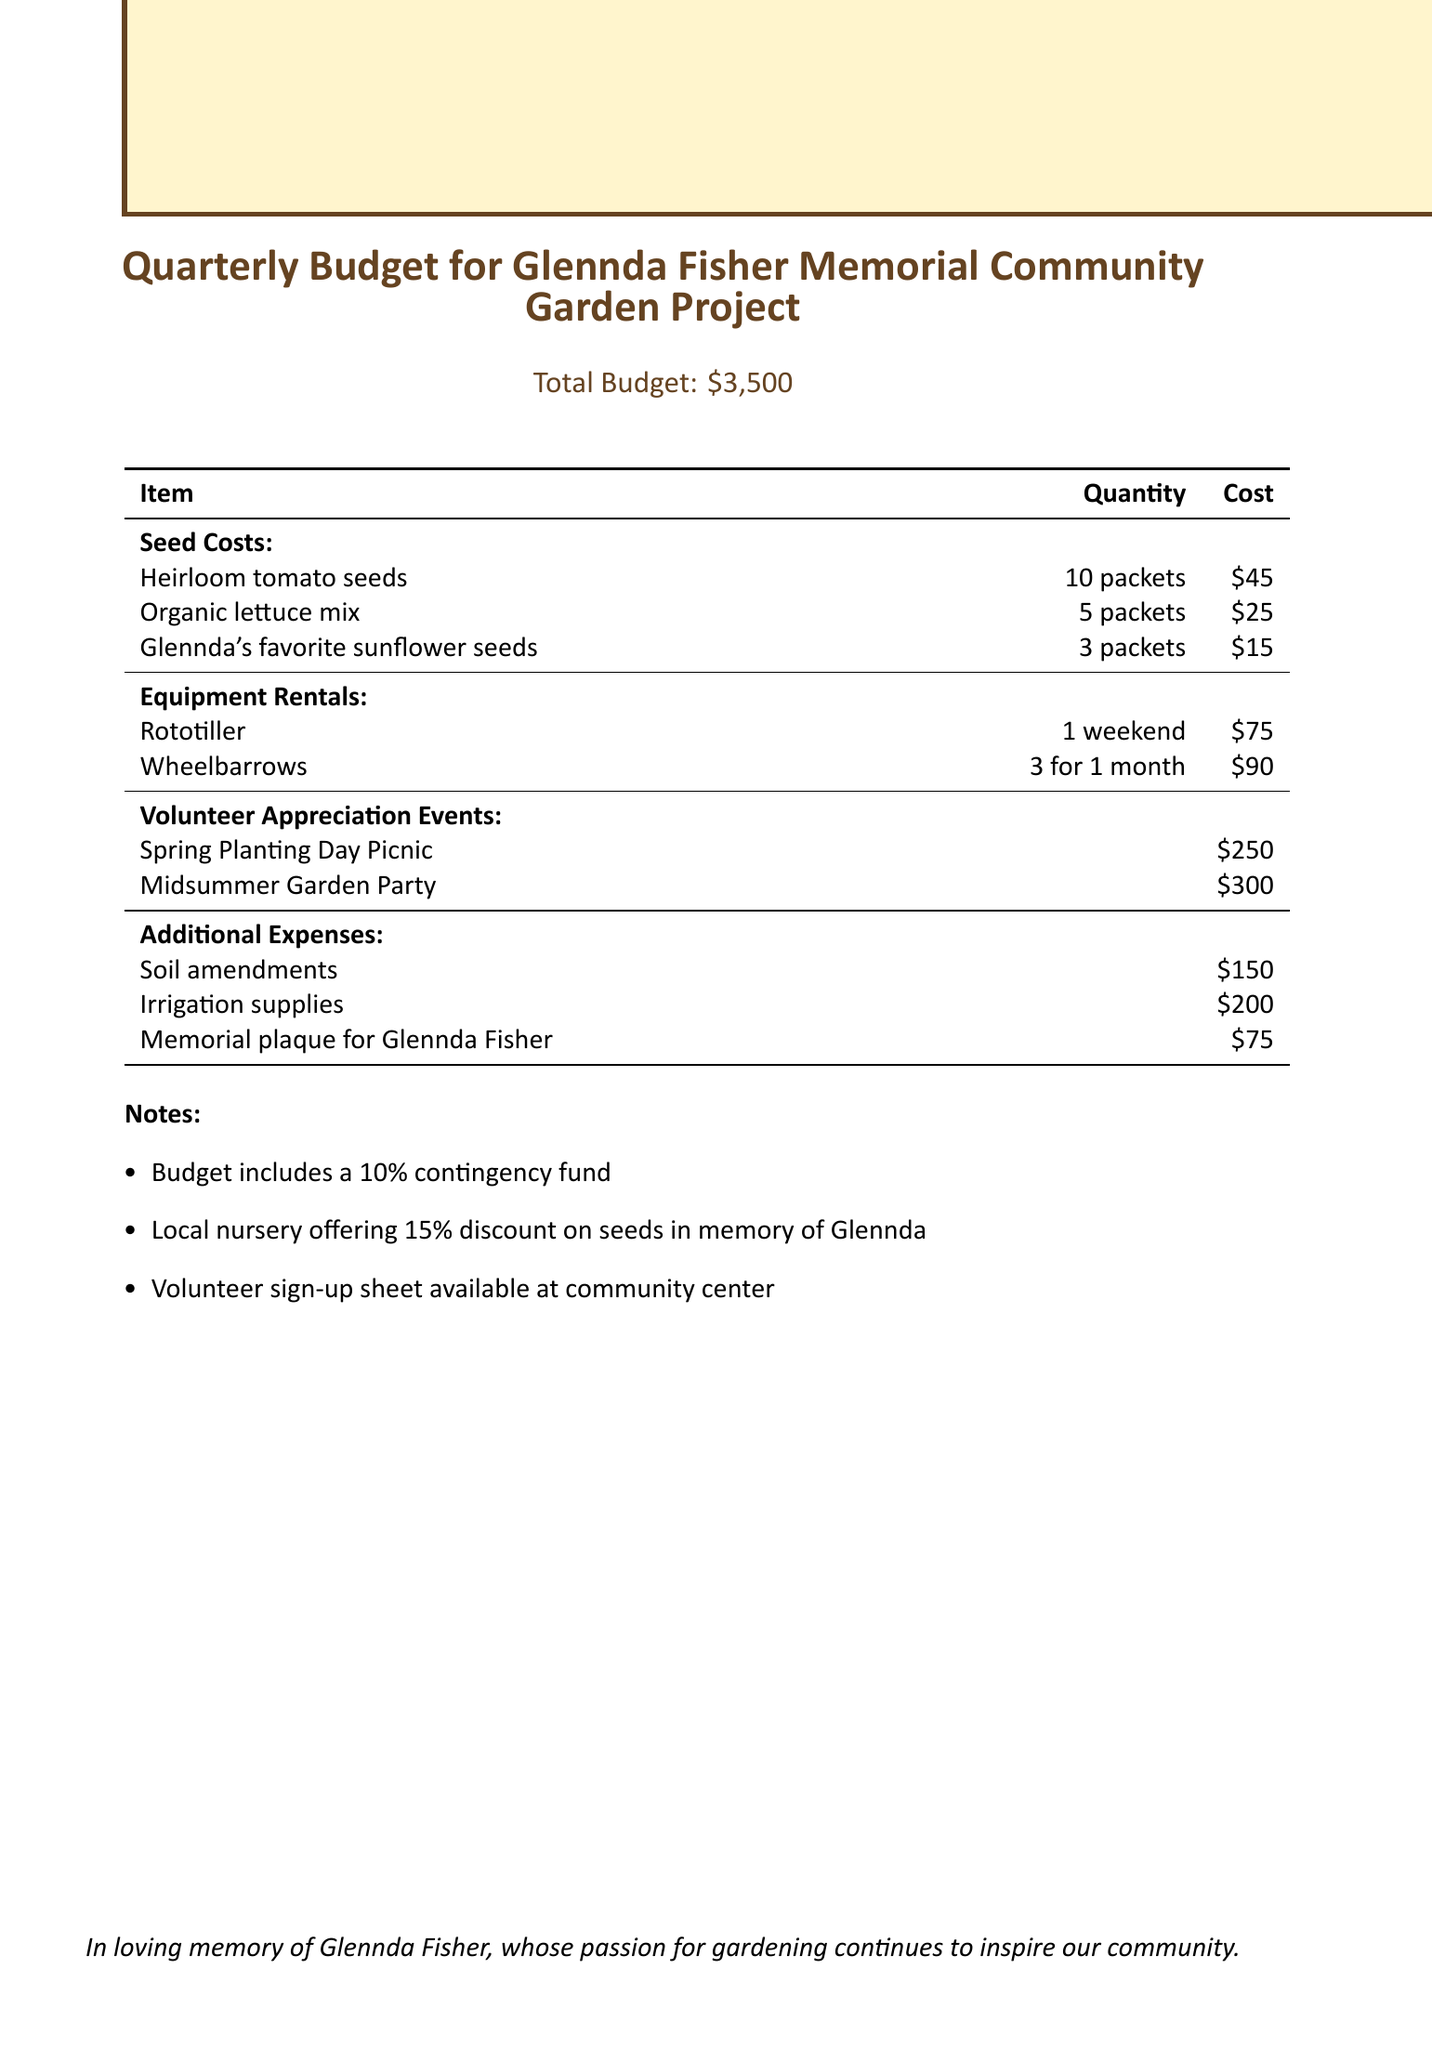What is the total budget? The total budget is stated at the beginning of the document as $3,500.
Answer: $3,500 How many packets of organic lettuce mix are included? The document specifies that there are 5 packets of organic lettuce mix.
Answer: 5 packets What is the cost of the memorial plaque for Glennda Fisher? The cost of the memorial plaque is listed in the additional expenses as $75.
Answer: $75 What percentage discount is offered by the local nursery on seeds? The document states that the local nursery offers a 15% discount on seeds.
Answer: 15% What event costs the most for volunteer appreciation? The document lists the Midsummer Garden Party as the most expensive event at $300.
Answer: Midsummer Garden Party How many wheelbarrows are rented, and for what duration? The document indicates that 3 wheelbarrows are rented for 1 month.
Answer: 3 for 1 month What is included in the budget as a contingency fund percentage? The budget includes a 10% contingency fund according to the notes.
Answer: 10% What type of seeds are Glennda's favorite? Glennda's favorite seeds mentioned in the document are sunflower seeds.
Answer: Sunflower seeds 